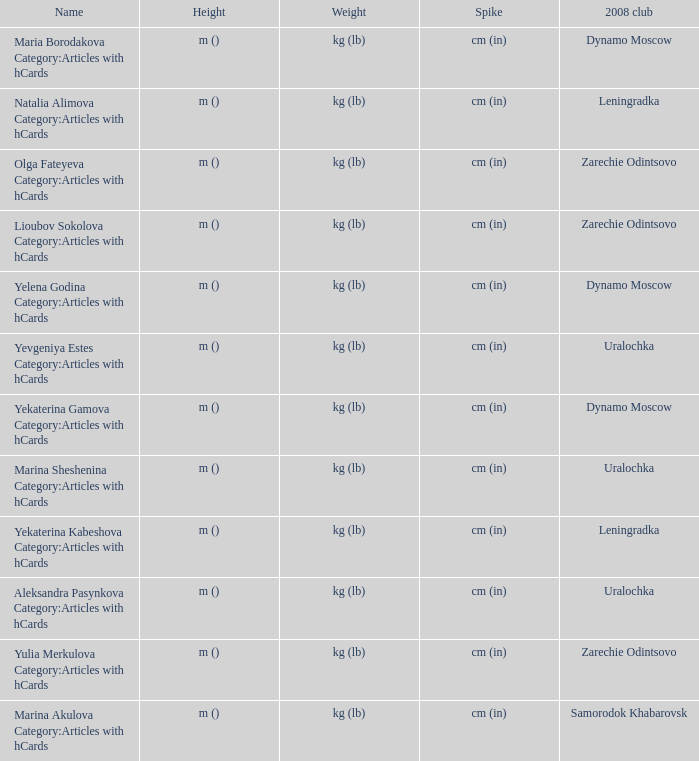What is the designation of the 2008 club identified as zarechie odintsovo? Olga Fateyeva Category:Articles with hCards, Lioubov Sokolova Category:Articles with hCards, Yulia Merkulova Category:Articles with hCards. 